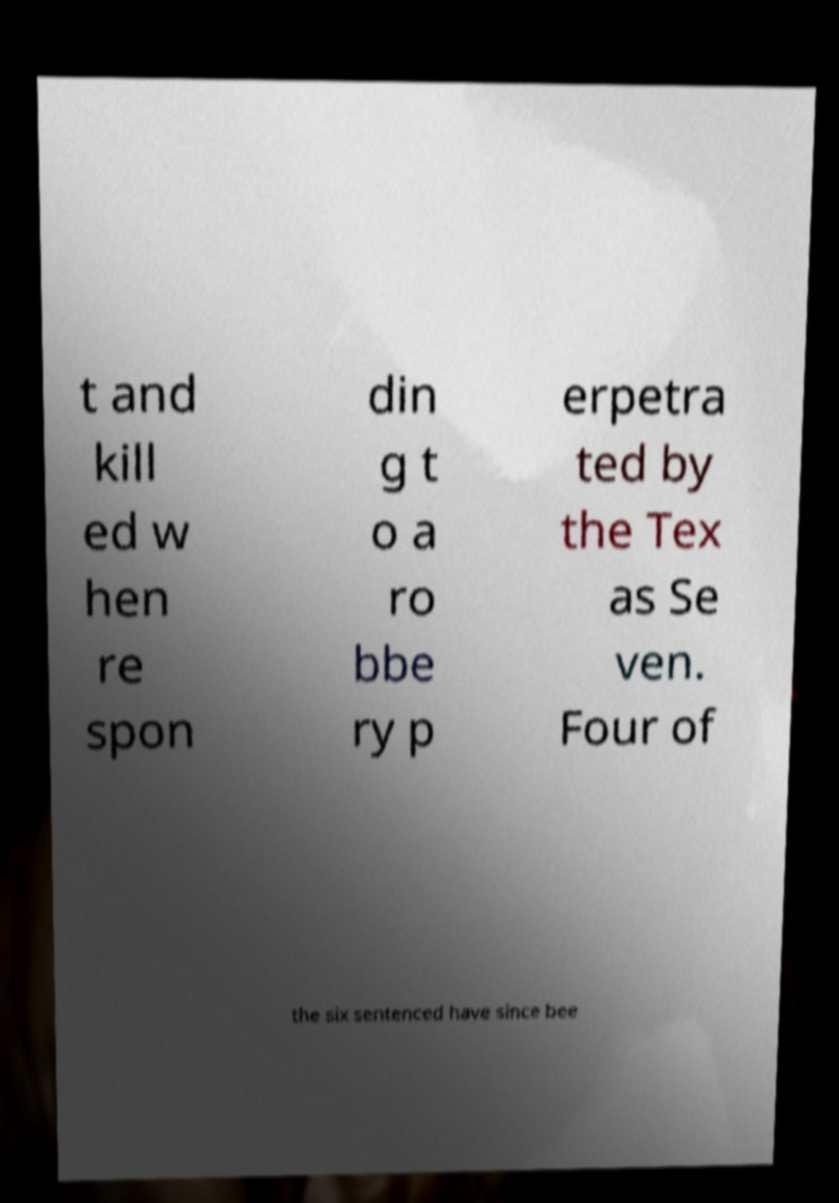Please read and relay the text visible in this image. What does it say? t and kill ed w hen re spon din g t o a ro bbe ry p erpetra ted by the Tex as Se ven. Four of the six sentenced have since bee 